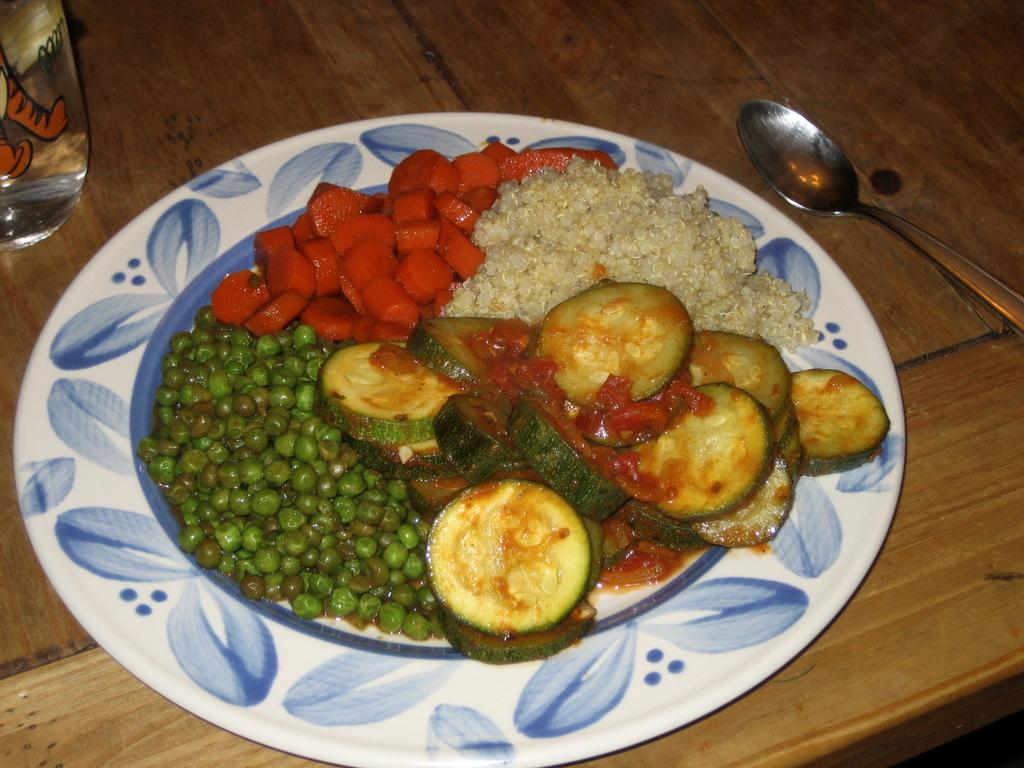What is the main subject of the image? The main subject of the image is food in a plate. Where is the plate located in the image? The plate is in the center of the image. What utensil can be seen in the image? A spoon is placed on the table. Reasoning: Let's think step by following the guidelines to produce the conversation. We start by identifying the main subject of the image, which is the food in a plate. Then, we describe the location of the plate, which is in the center of the image. Finally, we mention the presence of a spoon on the table. We avoid yes/no questions and ensure that the language is simple and clear. Absurd Question/Answer: What type of footwear is visible on the person in the image? There is no person visible in the image, only a plate of food and a spoon on the table. Can you tell me how many jars are present in the image? There are no jars present in the image; it only features a plate of food and a spoon on the table. What type of spacecraft can be seen in the image? There is no spacecraft present in the image; it only features a plate of food and a spoon on the table. 